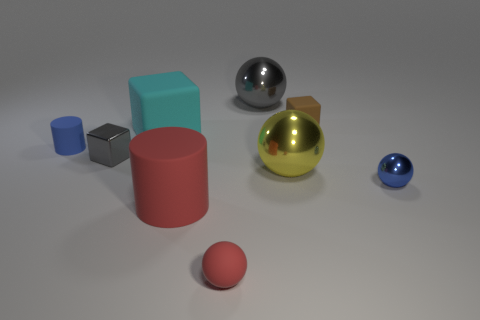Subtract 1 balls. How many balls are left? 3 Add 1 purple cylinders. How many objects exist? 10 Subtract all green spheres. Subtract all gray cylinders. How many spheres are left? 4 Subtract all cylinders. How many objects are left? 7 Subtract all blue cylinders. Subtract all large red things. How many objects are left? 7 Add 8 large metal balls. How many large metal balls are left? 10 Add 4 tiny things. How many tiny things exist? 9 Subtract 0 red cubes. How many objects are left? 9 